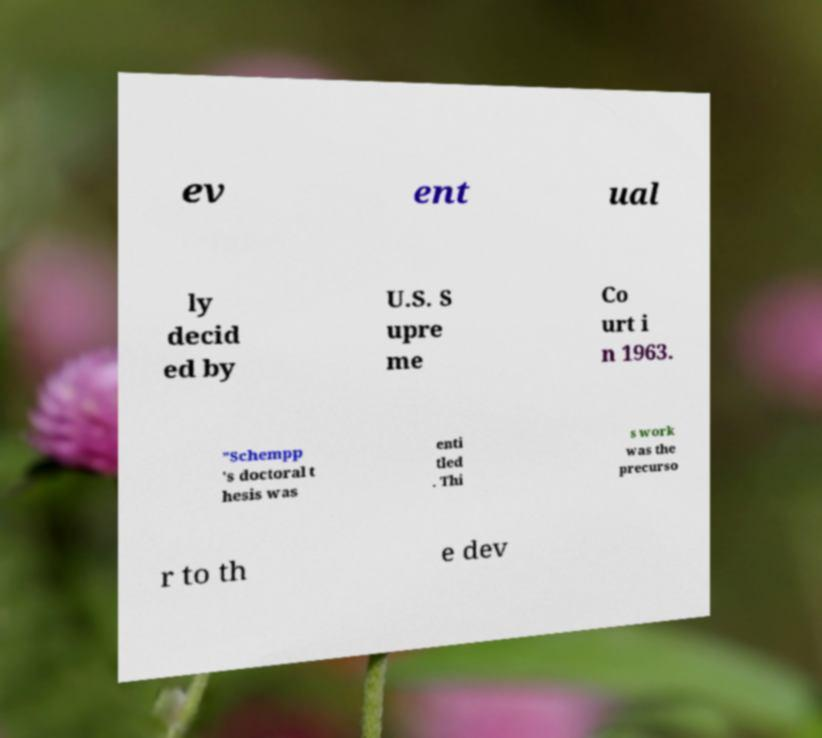Could you assist in decoding the text presented in this image and type it out clearly? ev ent ual ly decid ed by U.S. S upre me Co urt i n 1963. ”Schempp 's doctoral t hesis was enti tled . Thi s work was the precurso r to th e dev 